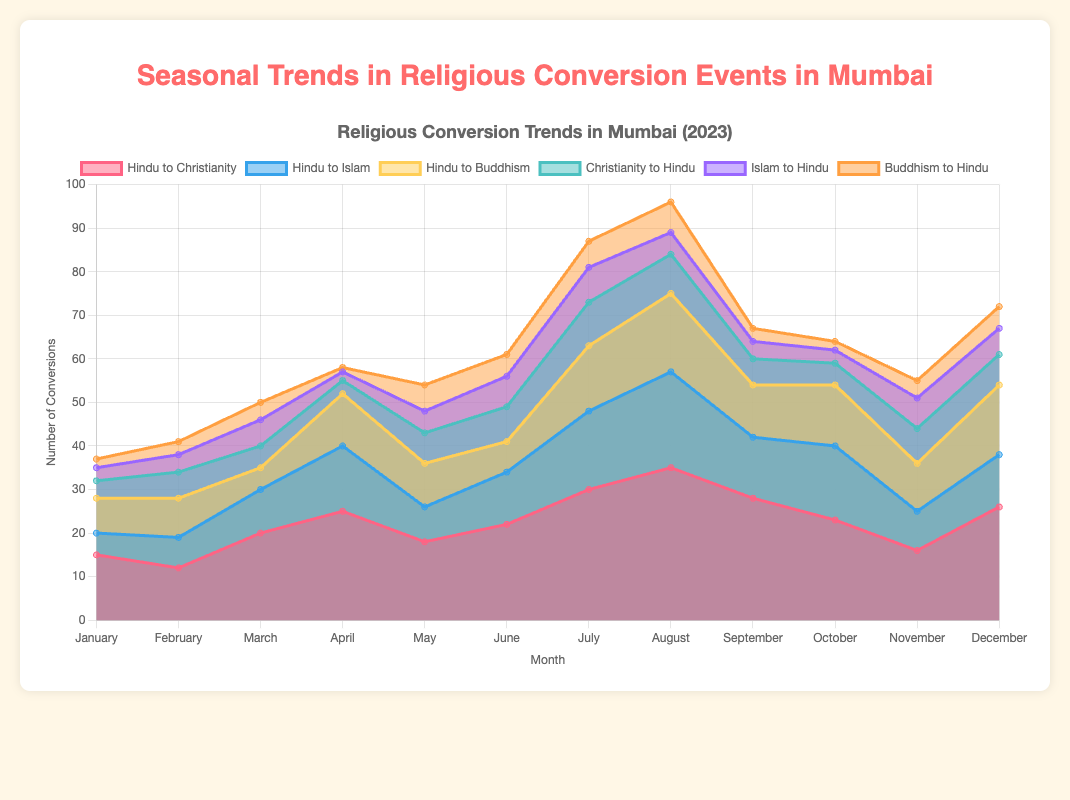What are the overall trends in the conversion of Hindus to Christianity throughout the year? Based on the visual information shown in the area chart, the number of Hindu to Christianity conversions increases gradually. It starts from 15 events in January, rising steadily to 35 events in August, and then declines again towards the end of the year to 26 events in December
Answer: The trend increases from January to August and then decreases Which month has the highest number of Hindu to Buddhism conversions? To find the highest number, inspect the 'Hindu to Buddhism' dataset and identify the maximum value, which is 18 events. Then, locate the corresponding month in the x-axis (August)
Answer: August Compare the number of conversions from Islam to Hinduism in January and July. Which month had more conversions? Compare the data points for 'Islam to Hindu' conversions in January (3 events) and July (8 events). Since 8 is greater than 3, July has more conversions
Answer: July What is the total number of conversions from any religion to Hinduism in December? Sum the December conversions to Hinduism from Christianity (7), Islam (6), and Buddhism (5). The calculation is 7 + 6 + 5 = 18
Answer: 18 Is there a seasonal pattern in 'Hindu to Islam' conversions, such as more conversions during certain months? Examine the area representing 'Hindu to Islam' conversions. The significant increase is noted from January (5 events) to August (22 events), and then it decreases again towards the year-end. This indicates higher conversions during mid-year, particularly in August
Answer: Higher mid-year, peaking in August In which month do Hindu to Christianity conversions exceed Hindu to Buddhism conversions by the largest margin? Check the differences between 'Hindu to Christianity' and 'Hindu to Buddhism' conversions each month. The largest difference is in August: Christianity (35) – Buddhism (18) = 17
Answer: August How do the conversions from Buddhism to Hinduism vary between the first half (January - June) and the second half (July - December) of the year? Sum the conversions from January to June: (2 + 3 + 4 + 1 + 6 + 5 = 21) and from July to December: (6 + 7 + 3 + 2 + 4 + 5 = 27). Then compare the two totals
Answer: They increase in the second half Identify the month with the lowest total number of religious conversion events for all categories combined. Sum the conversions of all types for each month, and the lowest is January: (15 + 5 + 8 + 4 + 3 + 2 = 37), compared to the other months
Answer: January Compare the number of conversions from Christianity to Hinduism in March and October. Which is higher and by how many? Pull the data points for 'Christianity to Hindu' conversions: March (5) and October (5). Since they are the same, the difference is 0
Answer: Same, 0 In which month did Hindu to Islam conversions surpass those of Hindu to Buddhism significantly? Compare the data points where the difference 'Hindu to Islam' > 'Hindu to Buddhism' is largest; April has the highest significant difference: Islam (15) – Buddhism (12) = 3
Answer: April 